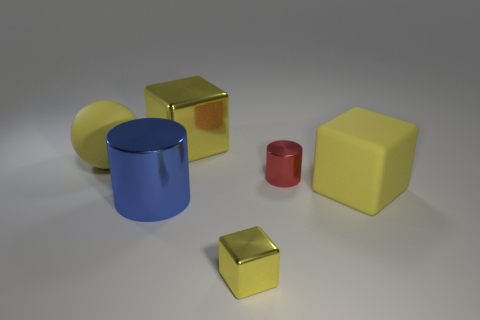Are there fewer red metallic objects left of the big cylinder than blue metal cylinders on the right side of the small red shiny object?
Give a very brief answer. No. There is a large rubber object left of the yellow metallic block in front of the big yellow matte sphere; what is its shape?
Provide a short and direct response. Sphere. What number of other objects are there of the same material as the big sphere?
Make the answer very short. 1. Is there anything else that has the same size as the blue shiny thing?
Provide a succinct answer. Yes. Is the number of big cubes greater than the number of tiny cylinders?
Your answer should be compact. Yes. What size is the yellow thing that is right of the red cylinder on the left side of the rubber object on the right side of the red thing?
Ensure brevity in your answer.  Large. There is a red metallic cylinder; is it the same size as the matte ball left of the large blue shiny thing?
Provide a succinct answer. No. Are there fewer large yellow metallic things that are in front of the big yellow rubber block than yellow shiny cubes?
Your answer should be very brief. Yes. How many large shiny things have the same color as the tiny block?
Offer a very short reply. 1. Is the number of big yellow cubes less than the number of brown metallic spheres?
Your answer should be very brief. No. 